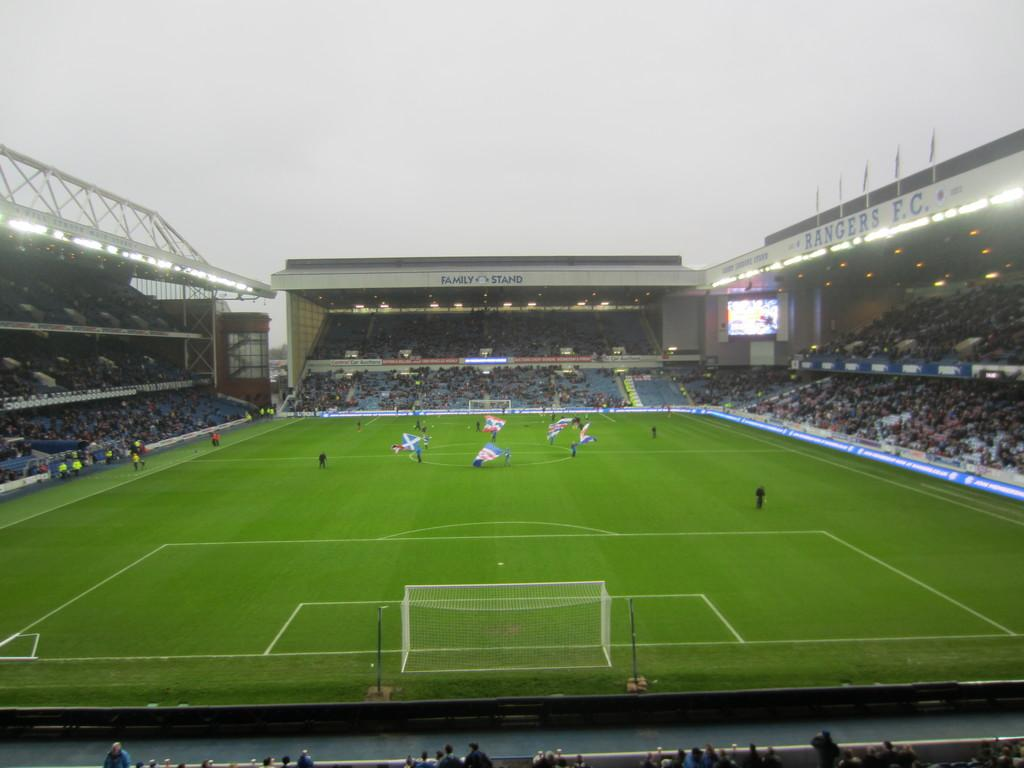<image>
Render a clear and concise summary of the photo. a soccer field with a side building that says 'family stand' on it 